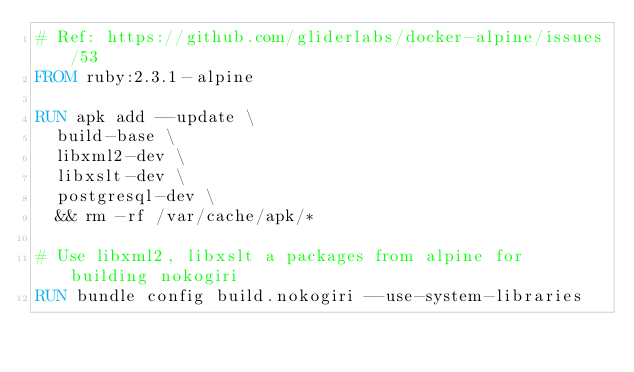<code> <loc_0><loc_0><loc_500><loc_500><_Dockerfile_># Ref: https://github.com/gliderlabs/docker-alpine/issues/53
FROM ruby:2.3.1-alpine

RUN apk add --update \
  build-base \
  libxml2-dev \
  libxslt-dev \
  postgresql-dev \
  && rm -rf /var/cache/apk/*

# Use libxml2, libxslt a packages from alpine for building nokogiri
RUN bundle config build.nokogiri --use-system-libraries
</code> 